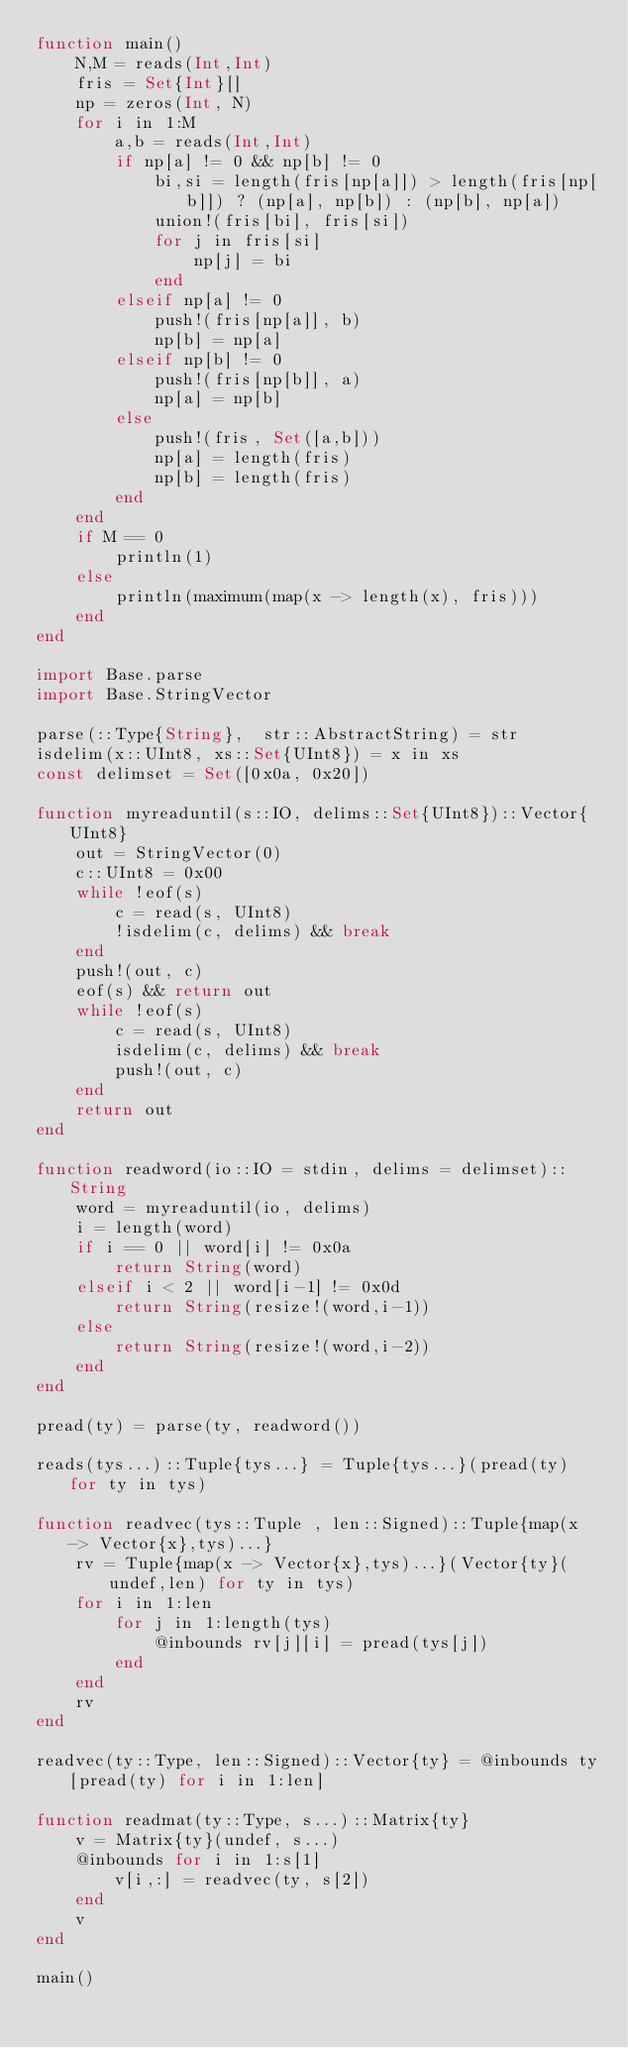Convert code to text. <code><loc_0><loc_0><loc_500><loc_500><_Julia_>function main()
    N,M = reads(Int,Int)
    fris = Set{Int}[]
    np = zeros(Int, N)
    for i in 1:M
        a,b = reads(Int,Int)
        if np[a] != 0 && np[b] != 0
            bi,si = length(fris[np[a]]) > length(fris[np[b]]) ? (np[a], np[b]) : (np[b], np[a])
            union!(fris[bi], fris[si])
            for j in fris[si]
                np[j] = bi
            end
        elseif np[a] != 0
            push!(fris[np[a]], b)
            np[b] = np[a]
        elseif np[b] != 0
            push!(fris[np[b]], a)
            np[a] = np[b]
        else
            push!(fris, Set([a,b]))
            np[a] = length(fris)
            np[b] = length(fris)
        end
    end
    if M == 0
        println(1)
    else
        println(maximum(map(x -> length(x), fris)))
    end
end

import Base.parse
import Base.StringVector

parse(::Type{String},  str::AbstractString) = str
isdelim(x::UInt8, xs::Set{UInt8}) = x in xs
const delimset = Set([0x0a, 0x20])

function myreaduntil(s::IO, delims::Set{UInt8})::Vector{UInt8}
    out = StringVector(0)
    c::UInt8 = 0x00
    while !eof(s)
        c = read(s, UInt8)
        !isdelim(c, delims) && break
    end
    push!(out, c)
    eof(s) && return out
    while !eof(s)
        c = read(s, UInt8)
        isdelim(c, delims) && break
        push!(out, c)
    end
    return out
end

function readword(io::IO = stdin, delims = delimset)::String
    word = myreaduntil(io, delims)
    i = length(word)
    if i == 0 || word[i] != 0x0a
        return String(word)
    elseif i < 2 || word[i-1] != 0x0d
        return String(resize!(word,i-1))
    else
        return String(resize!(word,i-2))
    end
end

pread(ty) = parse(ty, readword())

reads(tys...)::Tuple{tys...} = Tuple{tys...}(pread(ty) for ty in tys)

function readvec(tys::Tuple , len::Signed)::Tuple{map(x -> Vector{x},tys)...}
    rv = Tuple{map(x -> Vector{x},tys)...}(Vector{ty}(undef,len) for ty in tys)
    for i in 1:len
        for j in 1:length(tys)
            @inbounds rv[j][i] = pread(tys[j])
        end
    end
    rv
end

readvec(ty::Type, len::Signed)::Vector{ty} = @inbounds ty[pread(ty) for i in 1:len]

function readmat(ty::Type, s...)::Matrix{ty}
    v = Matrix{ty}(undef, s...)
    @inbounds for i in 1:s[1]
        v[i,:] = readvec(ty, s[2])
    end
    v
end

main()
</code> 